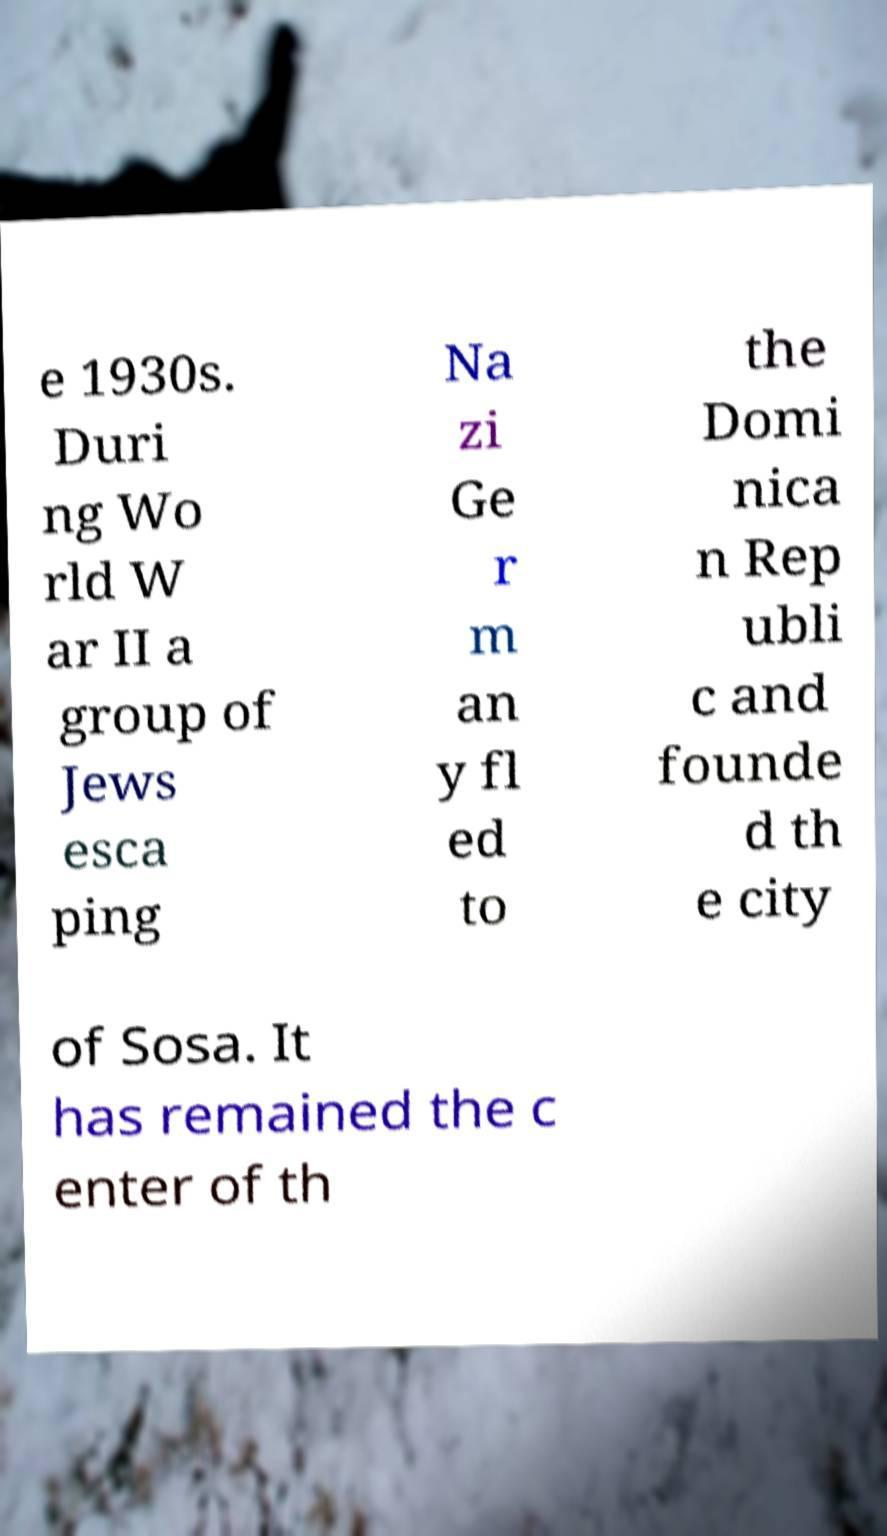Please identify and transcribe the text found in this image. e 1930s. Duri ng Wo rld W ar II a group of Jews esca ping Na zi Ge r m an y fl ed to the Domi nica n Rep ubli c and founde d th e city of Sosa. It has remained the c enter of th 